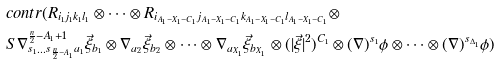<formula> <loc_0><loc_0><loc_500><loc_500>& c o n t r ( R _ { i _ { 1 } j _ { 1 } k _ { 1 } l _ { 1 } } \otimes \dots \otimes R _ { i _ { A _ { 1 } - X _ { 1 } - C _ { 1 } } j _ { A _ { 1 } - X _ { 1 } - C _ { 1 } } k _ { A _ { 1 } - X _ { 1 } - C _ { 1 } } l _ { A _ { 1 } - X _ { 1 } - C _ { 1 } } } \otimes \\ & S \nabla ^ { \frac { n } { 2 } - A _ { 1 } + 1 } _ { s _ { 1 } \dots s _ { \frac { n } { 2 } - A _ { 1 } } a _ { 1 } } \vec { \xi } _ { b _ { 1 } } \otimes \nabla _ { a _ { 2 } } \vec { \xi } _ { b _ { 2 } } \otimes \dots \otimes \nabla _ { a _ { X _ { 1 } } } \vec { \xi } _ { b _ { X _ { 1 } } } \otimes ( | \vec { \xi } | ^ { 2 } ) ^ { C _ { 1 } } \otimes ( \nabla ) ^ { s _ { 1 } } \phi \otimes \dots \otimes ( \nabla ) ^ { s _ { \Delta _ { 1 } } } \phi )</formula> 